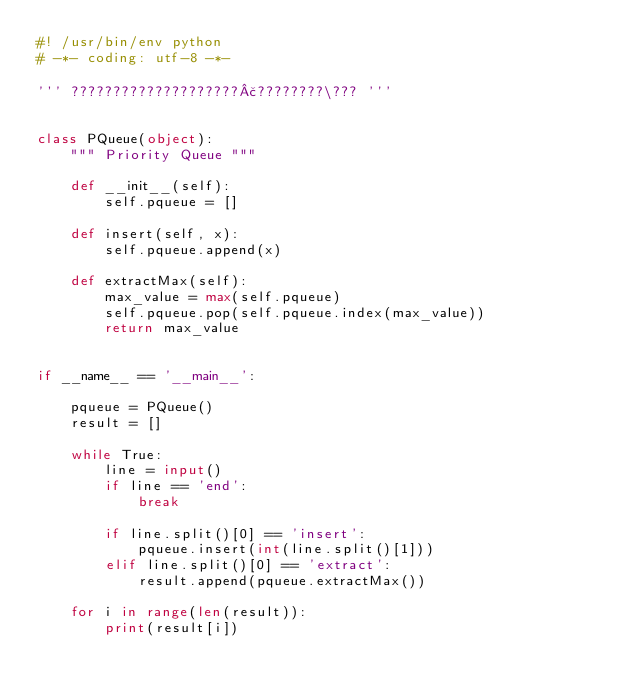<code> <loc_0><loc_0><loc_500><loc_500><_Python_>#! /usr/bin/env python
# -*- coding: utf-8 -*-

''' ????????????????????£????????\??? '''


class PQueue(object):
    """ Priority Queue """

    def __init__(self):
        self.pqueue = []

    def insert(self, x):
        self.pqueue.append(x)

    def extractMax(self):
        max_value = max(self.pqueue)
        self.pqueue.pop(self.pqueue.index(max_value))
        return max_value


if __name__ == '__main__':

    pqueue = PQueue()
    result = []

    while True:
        line = input()
        if line == 'end':
            break

        if line.split()[0] == 'insert':
            pqueue.insert(int(line.split()[1]))
        elif line.split()[0] == 'extract':
            result.append(pqueue.extractMax())

    for i in range(len(result)):
        print(result[i])</code> 